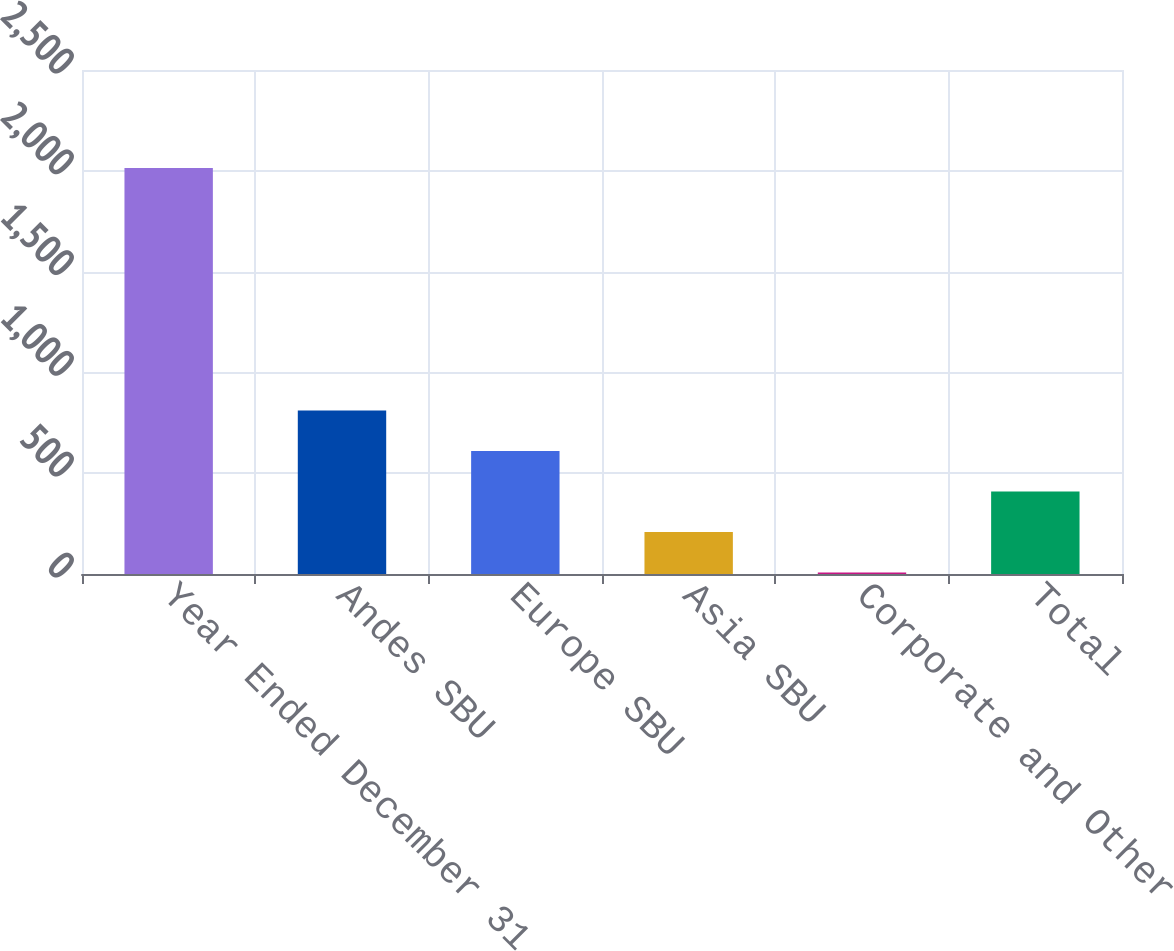Convert chart. <chart><loc_0><loc_0><loc_500><loc_500><bar_chart><fcel>Year Ended December 31<fcel>Andes SBU<fcel>Europe SBU<fcel>Asia SBU<fcel>Corporate and Other<fcel>Total<nl><fcel>2014<fcel>810.4<fcel>609.8<fcel>208.6<fcel>8<fcel>409.2<nl></chart> 